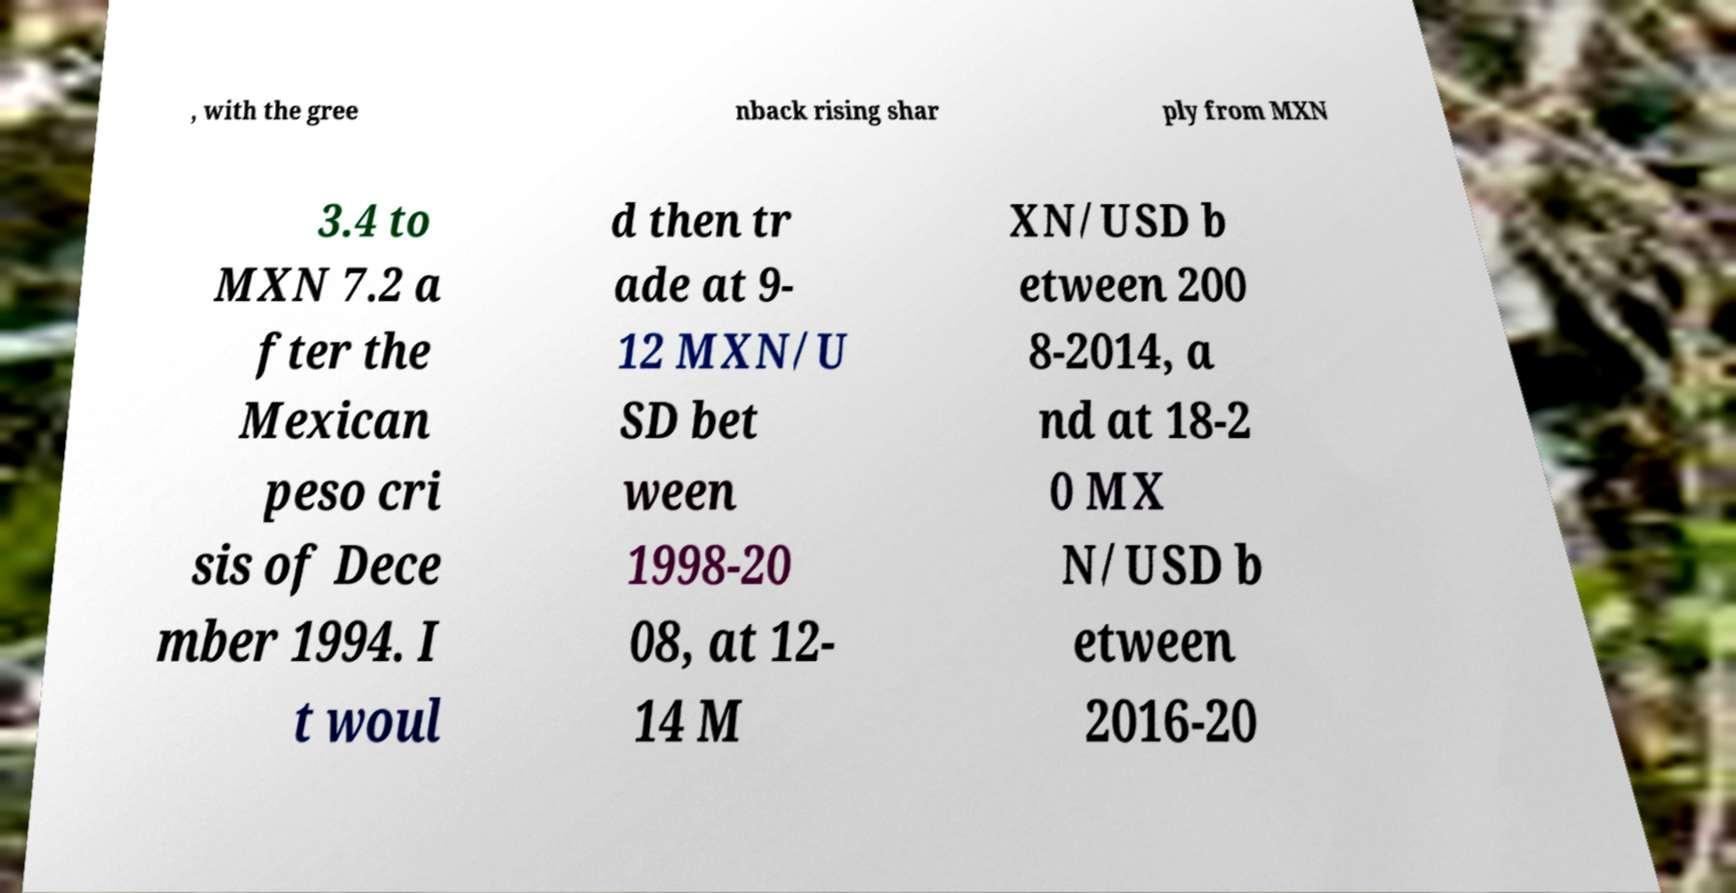For documentation purposes, I need the text within this image transcribed. Could you provide that? , with the gree nback rising shar ply from MXN 3.4 to MXN 7.2 a fter the Mexican peso cri sis of Dece mber 1994. I t woul d then tr ade at 9- 12 MXN/U SD bet ween 1998-20 08, at 12- 14 M XN/USD b etween 200 8-2014, a nd at 18-2 0 MX N/USD b etween 2016-20 